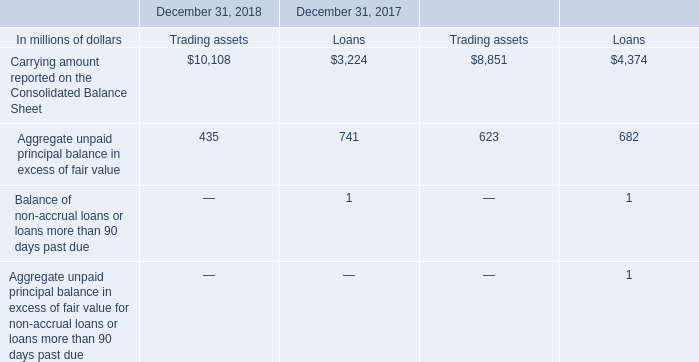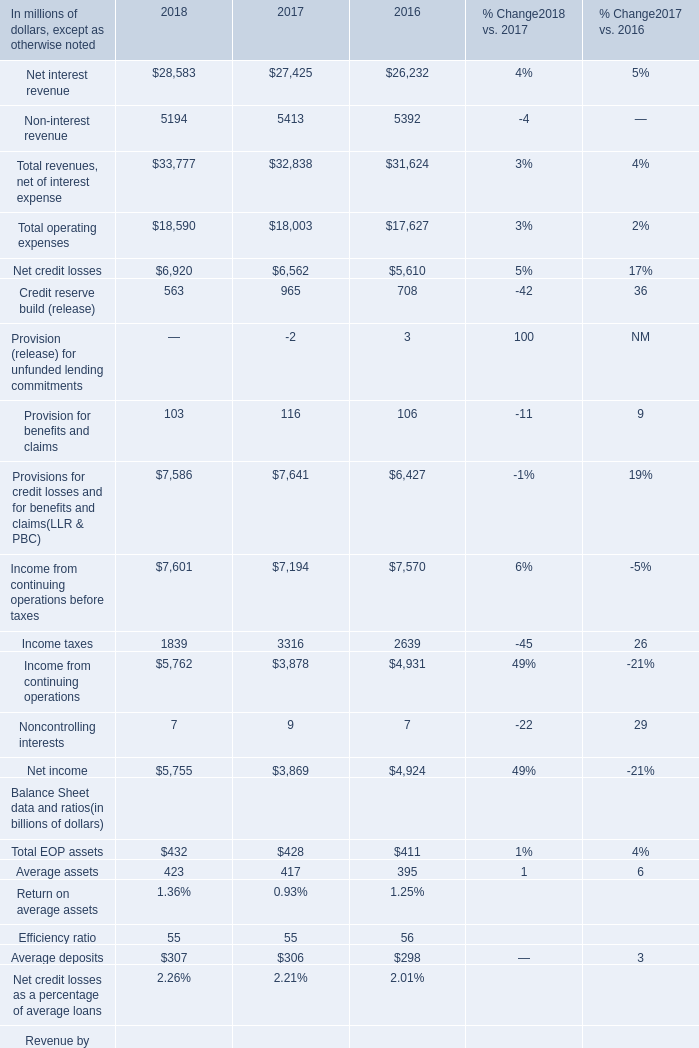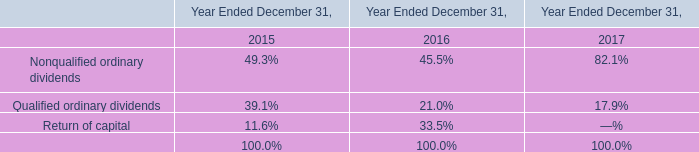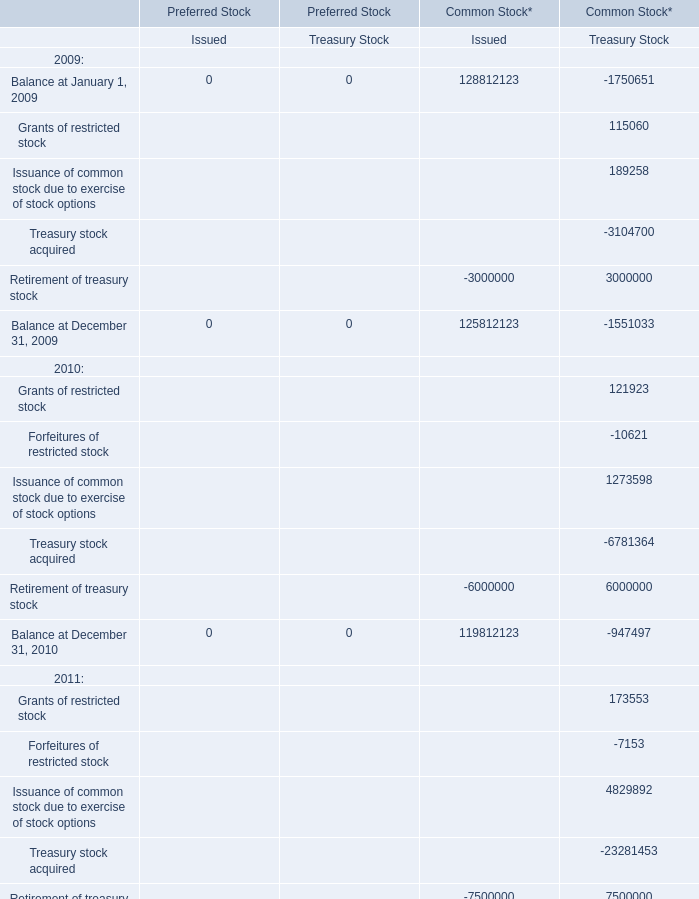What is the total amount of Balance at December 31, 2009 of Common Stock* Treasury Stock, and Income from continuing operations of 2017 ? 
Computations: (1551033.0 + 3878.0)
Answer: 1554911.0. 